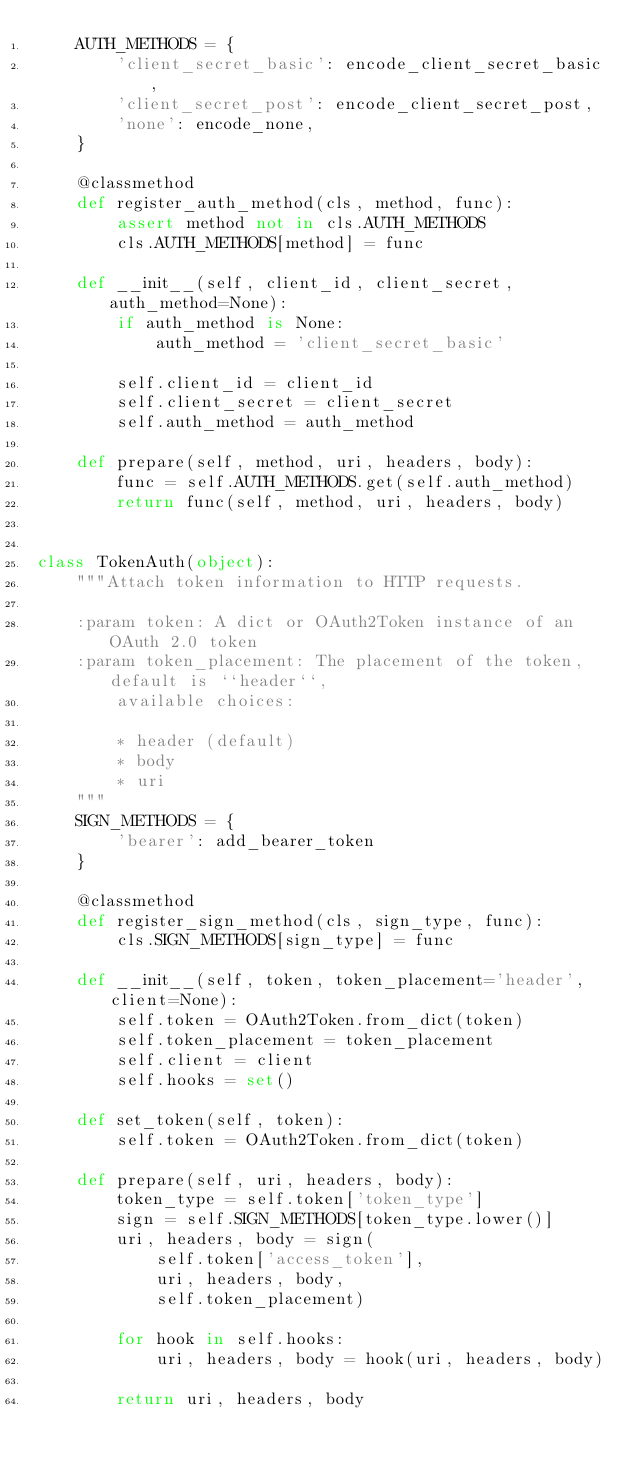Convert code to text. <code><loc_0><loc_0><loc_500><loc_500><_Python_>    AUTH_METHODS = {
        'client_secret_basic': encode_client_secret_basic,
        'client_secret_post': encode_client_secret_post,
        'none': encode_none,
    }

    @classmethod
    def register_auth_method(cls, method, func):
        assert method not in cls.AUTH_METHODS
        cls.AUTH_METHODS[method] = func

    def __init__(self, client_id, client_secret, auth_method=None):
        if auth_method is None:
            auth_method = 'client_secret_basic'

        self.client_id = client_id
        self.client_secret = client_secret
        self.auth_method = auth_method

    def prepare(self, method, uri, headers, body):
        func = self.AUTH_METHODS.get(self.auth_method)
        return func(self, method, uri, headers, body)


class TokenAuth(object):
    """Attach token information to HTTP requests.

    :param token: A dict or OAuth2Token instance of an OAuth 2.0 token
    :param token_placement: The placement of the token, default is ``header``,
        available choices:

        * header (default)
        * body
        * uri
    """
    SIGN_METHODS = {
        'bearer': add_bearer_token
    }

    @classmethod
    def register_sign_method(cls, sign_type, func):
        cls.SIGN_METHODS[sign_type] = func

    def __init__(self, token, token_placement='header', client=None):
        self.token = OAuth2Token.from_dict(token)
        self.token_placement = token_placement
        self.client = client
        self.hooks = set()

    def set_token(self, token):
        self.token = OAuth2Token.from_dict(token)

    def prepare(self, uri, headers, body):
        token_type = self.token['token_type']
        sign = self.SIGN_METHODS[token_type.lower()]
        uri, headers, body = sign(
            self.token['access_token'],
            uri, headers, body,
            self.token_placement)

        for hook in self.hooks:
            uri, headers, body = hook(uri, headers, body)

        return uri, headers, body
</code> 